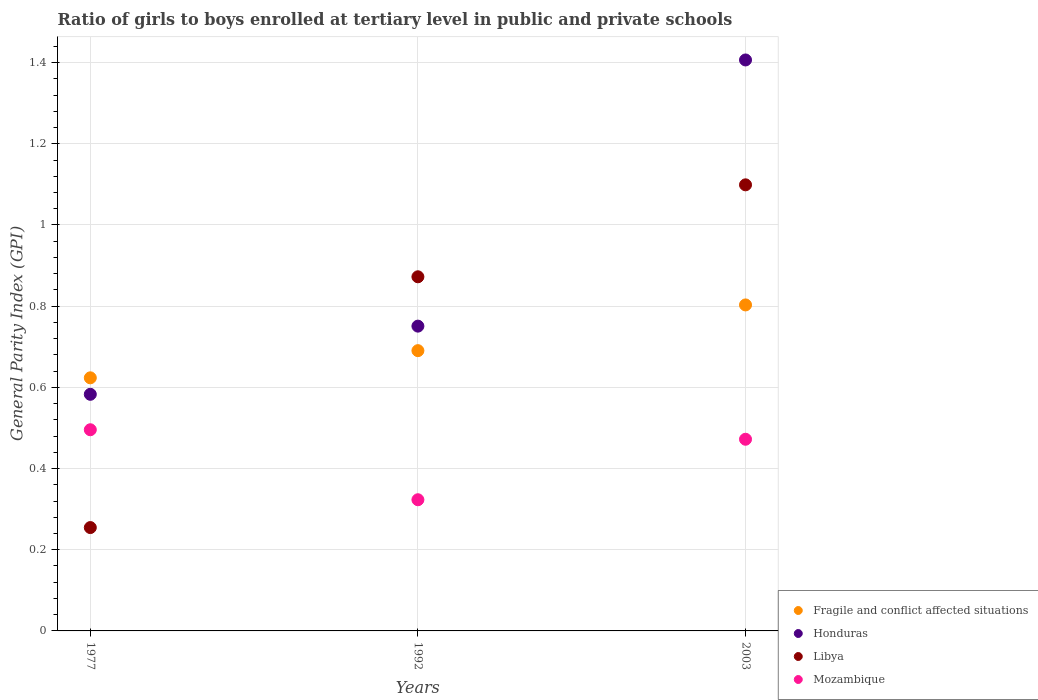What is the general parity index in Libya in 2003?
Your response must be concise. 1.1. Across all years, what is the maximum general parity index in Libya?
Ensure brevity in your answer.  1.1. Across all years, what is the minimum general parity index in Mozambique?
Your answer should be compact. 0.32. In which year was the general parity index in Libya maximum?
Give a very brief answer. 2003. What is the total general parity index in Mozambique in the graph?
Your answer should be very brief. 1.29. What is the difference between the general parity index in Honduras in 1977 and that in 2003?
Offer a very short reply. -0.82. What is the difference between the general parity index in Mozambique in 1992 and the general parity index in Honduras in 2003?
Make the answer very short. -1.08. What is the average general parity index in Fragile and conflict affected situations per year?
Offer a very short reply. 0.71. In the year 2003, what is the difference between the general parity index in Honduras and general parity index in Fragile and conflict affected situations?
Make the answer very short. 0.6. What is the ratio of the general parity index in Mozambique in 1977 to that in 2003?
Your answer should be compact. 1.05. What is the difference between the highest and the second highest general parity index in Libya?
Your answer should be compact. 0.23. What is the difference between the highest and the lowest general parity index in Mozambique?
Provide a succinct answer. 0.17. In how many years, is the general parity index in Mozambique greater than the average general parity index in Mozambique taken over all years?
Keep it short and to the point. 2. Is the sum of the general parity index in Fragile and conflict affected situations in 1992 and 2003 greater than the maximum general parity index in Mozambique across all years?
Your answer should be very brief. Yes. Is it the case that in every year, the sum of the general parity index in Libya and general parity index in Fragile and conflict affected situations  is greater than the general parity index in Mozambique?
Offer a very short reply. Yes. Does the general parity index in Honduras monotonically increase over the years?
Ensure brevity in your answer.  Yes. Is the general parity index in Honduras strictly greater than the general parity index in Mozambique over the years?
Offer a terse response. Yes. Is the general parity index in Fragile and conflict affected situations strictly less than the general parity index in Mozambique over the years?
Provide a short and direct response. No. How many dotlines are there?
Offer a terse response. 4. How many years are there in the graph?
Your response must be concise. 3. What is the difference between two consecutive major ticks on the Y-axis?
Your response must be concise. 0.2. What is the title of the graph?
Make the answer very short. Ratio of girls to boys enrolled at tertiary level in public and private schools. What is the label or title of the Y-axis?
Your answer should be compact. General Parity Index (GPI). What is the General Parity Index (GPI) in Fragile and conflict affected situations in 1977?
Offer a terse response. 0.62. What is the General Parity Index (GPI) in Honduras in 1977?
Your response must be concise. 0.58. What is the General Parity Index (GPI) in Libya in 1977?
Offer a terse response. 0.25. What is the General Parity Index (GPI) of Mozambique in 1977?
Ensure brevity in your answer.  0.5. What is the General Parity Index (GPI) of Fragile and conflict affected situations in 1992?
Give a very brief answer. 0.69. What is the General Parity Index (GPI) of Honduras in 1992?
Your answer should be compact. 0.75. What is the General Parity Index (GPI) in Libya in 1992?
Make the answer very short. 0.87. What is the General Parity Index (GPI) of Mozambique in 1992?
Offer a very short reply. 0.32. What is the General Parity Index (GPI) of Fragile and conflict affected situations in 2003?
Provide a succinct answer. 0.8. What is the General Parity Index (GPI) in Honduras in 2003?
Keep it short and to the point. 1.41. What is the General Parity Index (GPI) in Libya in 2003?
Your answer should be very brief. 1.1. What is the General Parity Index (GPI) of Mozambique in 2003?
Offer a very short reply. 0.47. Across all years, what is the maximum General Parity Index (GPI) in Fragile and conflict affected situations?
Provide a short and direct response. 0.8. Across all years, what is the maximum General Parity Index (GPI) of Honduras?
Your answer should be very brief. 1.41. Across all years, what is the maximum General Parity Index (GPI) of Libya?
Make the answer very short. 1.1. Across all years, what is the maximum General Parity Index (GPI) in Mozambique?
Your response must be concise. 0.5. Across all years, what is the minimum General Parity Index (GPI) of Fragile and conflict affected situations?
Your response must be concise. 0.62. Across all years, what is the minimum General Parity Index (GPI) in Honduras?
Your answer should be very brief. 0.58. Across all years, what is the minimum General Parity Index (GPI) in Libya?
Offer a very short reply. 0.25. Across all years, what is the minimum General Parity Index (GPI) of Mozambique?
Give a very brief answer. 0.32. What is the total General Parity Index (GPI) in Fragile and conflict affected situations in the graph?
Offer a very short reply. 2.12. What is the total General Parity Index (GPI) of Honduras in the graph?
Make the answer very short. 2.74. What is the total General Parity Index (GPI) of Libya in the graph?
Give a very brief answer. 2.23. What is the total General Parity Index (GPI) of Mozambique in the graph?
Give a very brief answer. 1.29. What is the difference between the General Parity Index (GPI) in Fragile and conflict affected situations in 1977 and that in 1992?
Provide a short and direct response. -0.07. What is the difference between the General Parity Index (GPI) in Honduras in 1977 and that in 1992?
Ensure brevity in your answer.  -0.17. What is the difference between the General Parity Index (GPI) in Libya in 1977 and that in 1992?
Your answer should be compact. -0.62. What is the difference between the General Parity Index (GPI) of Mozambique in 1977 and that in 1992?
Offer a terse response. 0.17. What is the difference between the General Parity Index (GPI) of Fragile and conflict affected situations in 1977 and that in 2003?
Your answer should be compact. -0.18. What is the difference between the General Parity Index (GPI) of Honduras in 1977 and that in 2003?
Keep it short and to the point. -0.82. What is the difference between the General Parity Index (GPI) of Libya in 1977 and that in 2003?
Your response must be concise. -0.84. What is the difference between the General Parity Index (GPI) of Mozambique in 1977 and that in 2003?
Offer a terse response. 0.02. What is the difference between the General Parity Index (GPI) of Fragile and conflict affected situations in 1992 and that in 2003?
Make the answer very short. -0.11. What is the difference between the General Parity Index (GPI) of Honduras in 1992 and that in 2003?
Ensure brevity in your answer.  -0.66. What is the difference between the General Parity Index (GPI) of Libya in 1992 and that in 2003?
Ensure brevity in your answer.  -0.23. What is the difference between the General Parity Index (GPI) in Mozambique in 1992 and that in 2003?
Your answer should be very brief. -0.15. What is the difference between the General Parity Index (GPI) in Fragile and conflict affected situations in 1977 and the General Parity Index (GPI) in Honduras in 1992?
Give a very brief answer. -0.13. What is the difference between the General Parity Index (GPI) of Fragile and conflict affected situations in 1977 and the General Parity Index (GPI) of Libya in 1992?
Your answer should be very brief. -0.25. What is the difference between the General Parity Index (GPI) of Fragile and conflict affected situations in 1977 and the General Parity Index (GPI) of Mozambique in 1992?
Your response must be concise. 0.3. What is the difference between the General Parity Index (GPI) of Honduras in 1977 and the General Parity Index (GPI) of Libya in 1992?
Your answer should be very brief. -0.29. What is the difference between the General Parity Index (GPI) in Honduras in 1977 and the General Parity Index (GPI) in Mozambique in 1992?
Offer a terse response. 0.26. What is the difference between the General Parity Index (GPI) of Libya in 1977 and the General Parity Index (GPI) of Mozambique in 1992?
Your response must be concise. -0.07. What is the difference between the General Parity Index (GPI) of Fragile and conflict affected situations in 1977 and the General Parity Index (GPI) of Honduras in 2003?
Offer a very short reply. -0.78. What is the difference between the General Parity Index (GPI) in Fragile and conflict affected situations in 1977 and the General Parity Index (GPI) in Libya in 2003?
Provide a succinct answer. -0.48. What is the difference between the General Parity Index (GPI) of Fragile and conflict affected situations in 1977 and the General Parity Index (GPI) of Mozambique in 2003?
Provide a short and direct response. 0.15. What is the difference between the General Parity Index (GPI) of Honduras in 1977 and the General Parity Index (GPI) of Libya in 2003?
Your answer should be compact. -0.52. What is the difference between the General Parity Index (GPI) of Honduras in 1977 and the General Parity Index (GPI) of Mozambique in 2003?
Offer a terse response. 0.11. What is the difference between the General Parity Index (GPI) of Libya in 1977 and the General Parity Index (GPI) of Mozambique in 2003?
Your response must be concise. -0.22. What is the difference between the General Parity Index (GPI) in Fragile and conflict affected situations in 1992 and the General Parity Index (GPI) in Honduras in 2003?
Provide a succinct answer. -0.72. What is the difference between the General Parity Index (GPI) of Fragile and conflict affected situations in 1992 and the General Parity Index (GPI) of Libya in 2003?
Provide a short and direct response. -0.41. What is the difference between the General Parity Index (GPI) of Fragile and conflict affected situations in 1992 and the General Parity Index (GPI) of Mozambique in 2003?
Your answer should be compact. 0.22. What is the difference between the General Parity Index (GPI) of Honduras in 1992 and the General Parity Index (GPI) of Libya in 2003?
Provide a succinct answer. -0.35. What is the difference between the General Parity Index (GPI) in Honduras in 1992 and the General Parity Index (GPI) in Mozambique in 2003?
Provide a succinct answer. 0.28. What is the difference between the General Parity Index (GPI) of Libya in 1992 and the General Parity Index (GPI) of Mozambique in 2003?
Make the answer very short. 0.4. What is the average General Parity Index (GPI) of Fragile and conflict affected situations per year?
Make the answer very short. 0.71. What is the average General Parity Index (GPI) of Honduras per year?
Make the answer very short. 0.91. What is the average General Parity Index (GPI) of Libya per year?
Offer a terse response. 0.74. What is the average General Parity Index (GPI) in Mozambique per year?
Offer a terse response. 0.43. In the year 1977, what is the difference between the General Parity Index (GPI) in Fragile and conflict affected situations and General Parity Index (GPI) in Honduras?
Give a very brief answer. 0.04. In the year 1977, what is the difference between the General Parity Index (GPI) of Fragile and conflict affected situations and General Parity Index (GPI) of Libya?
Ensure brevity in your answer.  0.37. In the year 1977, what is the difference between the General Parity Index (GPI) of Fragile and conflict affected situations and General Parity Index (GPI) of Mozambique?
Offer a terse response. 0.13. In the year 1977, what is the difference between the General Parity Index (GPI) of Honduras and General Parity Index (GPI) of Libya?
Your answer should be very brief. 0.33. In the year 1977, what is the difference between the General Parity Index (GPI) of Honduras and General Parity Index (GPI) of Mozambique?
Offer a very short reply. 0.09. In the year 1977, what is the difference between the General Parity Index (GPI) in Libya and General Parity Index (GPI) in Mozambique?
Give a very brief answer. -0.24. In the year 1992, what is the difference between the General Parity Index (GPI) in Fragile and conflict affected situations and General Parity Index (GPI) in Honduras?
Your answer should be compact. -0.06. In the year 1992, what is the difference between the General Parity Index (GPI) in Fragile and conflict affected situations and General Parity Index (GPI) in Libya?
Your response must be concise. -0.18. In the year 1992, what is the difference between the General Parity Index (GPI) of Fragile and conflict affected situations and General Parity Index (GPI) of Mozambique?
Give a very brief answer. 0.37. In the year 1992, what is the difference between the General Parity Index (GPI) of Honduras and General Parity Index (GPI) of Libya?
Your answer should be very brief. -0.12. In the year 1992, what is the difference between the General Parity Index (GPI) in Honduras and General Parity Index (GPI) in Mozambique?
Your answer should be very brief. 0.43. In the year 1992, what is the difference between the General Parity Index (GPI) in Libya and General Parity Index (GPI) in Mozambique?
Give a very brief answer. 0.55. In the year 2003, what is the difference between the General Parity Index (GPI) of Fragile and conflict affected situations and General Parity Index (GPI) of Honduras?
Provide a short and direct response. -0.6. In the year 2003, what is the difference between the General Parity Index (GPI) of Fragile and conflict affected situations and General Parity Index (GPI) of Libya?
Your answer should be compact. -0.3. In the year 2003, what is the difference between the General Parity Index (GPI) in Fragile and conflict affected situations and General Parity Index (GPI) in Mozambique?
Give a very brief answer. 0.33. In the year 2003, what is the difference between the General Parity Index (GPI) in Honduras and General Parity Index (GPI) in Libya?
Offer a very short reply. 0.31. In the year 2003, what is the difference between the General Parity Index (GPI) of Honduras and General Parity Index (GPI) of Mozambique?
Your response must be concise. 0.93. In the year 2003, what is the difference between the General Parity Index (GPI) in Libya and General Parity Index (GPI) in Mozambique?
Your answer should be compact. 0.63. What is the ratio of the General Parity Index (GPI) of Fragile and conflict affected situations in 1977 to that in 1992?
Your response must be concise. 0.9. What is the ratio of the General Parity Index (GPI) in Honduras in 1977 to that in 1992?
Offer a very short reply. 0.78. What is the ratio of the General Parity Index (GPI) of Libya in 1977 to that in 1992?
Offer a very short reply. 0.29. What is the ratio of the General Parity Index (GPI) of Mozambique in 1977 to that in 1992?
Your response must be concise. 1.53. What is the ratio of the General Parity Index (GPI) in Fragile and conflict affected situations in 1977 to that in 2003?
Your answer should be compact. 0.78. What is the ratio of the General Parity Index (GPI) in Honduras in 1977 to that in 2003?
Make the answer very short. 0.41. What is the ratio of the General Parity Index (GPI) in Libya in 1977 to that in 2003?
Give a very brief answer. 0.23. What is the ratio of the General Parity Index (GPI) of Mozambique in 1977 to that in 2003?
Your answer should be compact. 1.05. What is the ratio of the General Parity Index (GPI) of Fragile and conflict affected situations in 1992 to that in 2003?
Your response must be concise. 0.86. What is the ratio of the General Parity Index (GPI) in Honduras in 1992 to that in 2003?
Keep it short and to the point. 0.53. What is the ratio of the General Parity Index (GPI) in Libya in 1992 to that in 2003?
Your response must be concise. 0.79. What is the ratio of the General Parity Index (GPI) of Mozambique in 1992 to that in 2003?
Keep it short and to the point. 0.68. What is the difference between the highest and the second highest General Parity Index (GPI) of Fragile and conflict affected situations?
Offer a terse response. 0.11. What is the difference between the highest and the second highest General Parity Index (GPI) of Honduras?
Give a very brief answer. 0.66. What is the difference between the highest and the second highest General Parity Index (GPI) of Libya?
Give a very brief answer. 0.23. What is the difference between the highest and the second highest General Parity Index (GPI) of Mozambique?
Keep it short and to the point. 0.02. What is the difference between the highest and the lowest General Parity Index (GPI) in Fragile and conflict affected situations?
Your answer should be compact. 0.18. What is the difference between the highest and the lowest General Parity Index (GPI) of Honduras?
Keep it short and to the point. 0.82. What is the difference between the highest and the lowest General Parity Index (GPI) in Libya?
Offer a terse response. 0.84. What is the difference between the highest and the lowest General Parity Index (GPI) in Mozambique?
Keep it short and to the point. 0.17. 